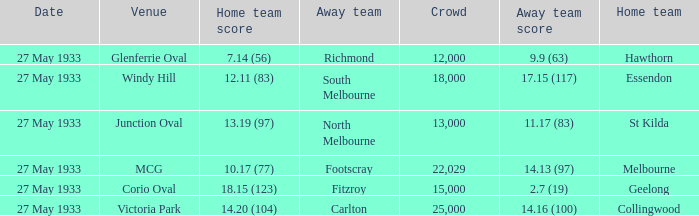In the match where the away team scored 2.7 (19), how many peopel were in the crowd? 15000.0. 